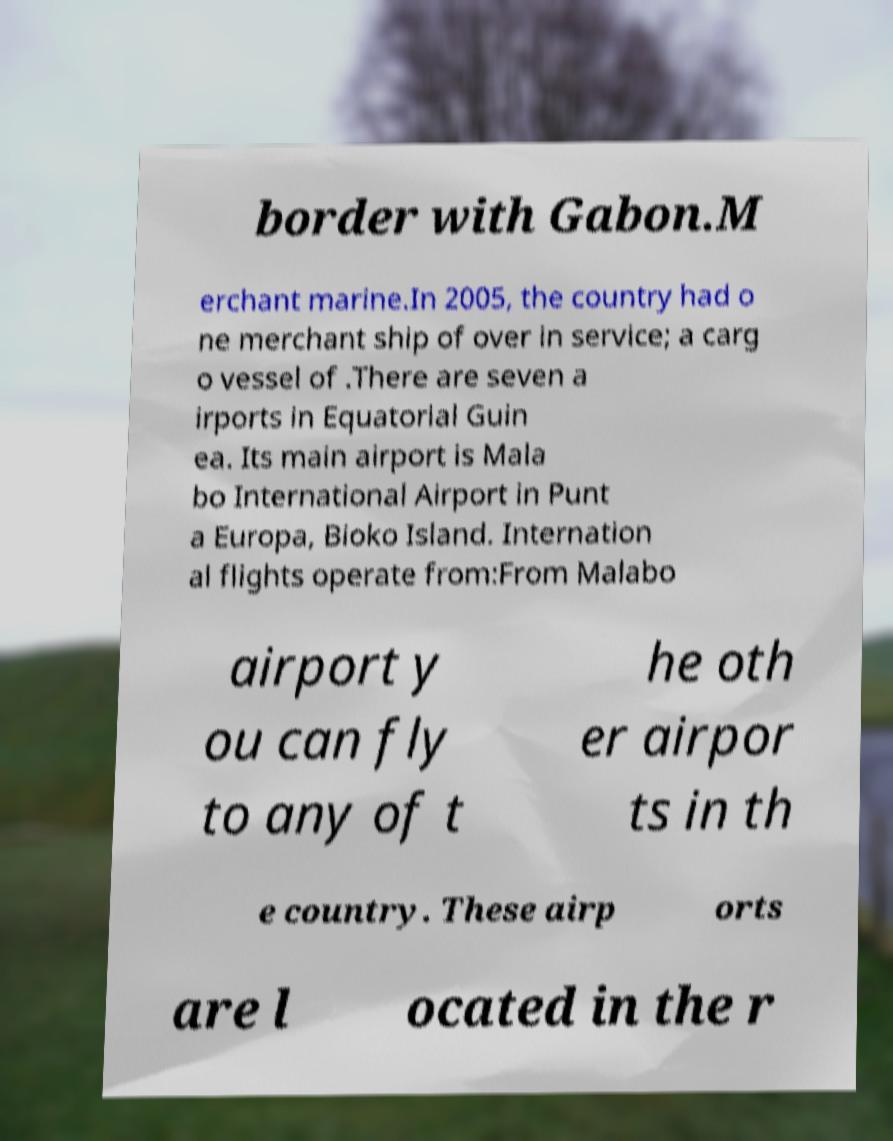Can you accurately transcribe the text from the provided image for me? border with Gabon.M erchant marine.In 2005, the country had o ne merchant ship of over in service; a carg o vessel of .There are seven a irports in Equatorial Guin ea. Its main airport is Mala bo International Airport in Punt a Europa, Bioko Island. Internation al flights operate from:From Malabo airport y ou can fly to any of t he oth er airpor ts in th e country. These airp orts are l ocated in the r 